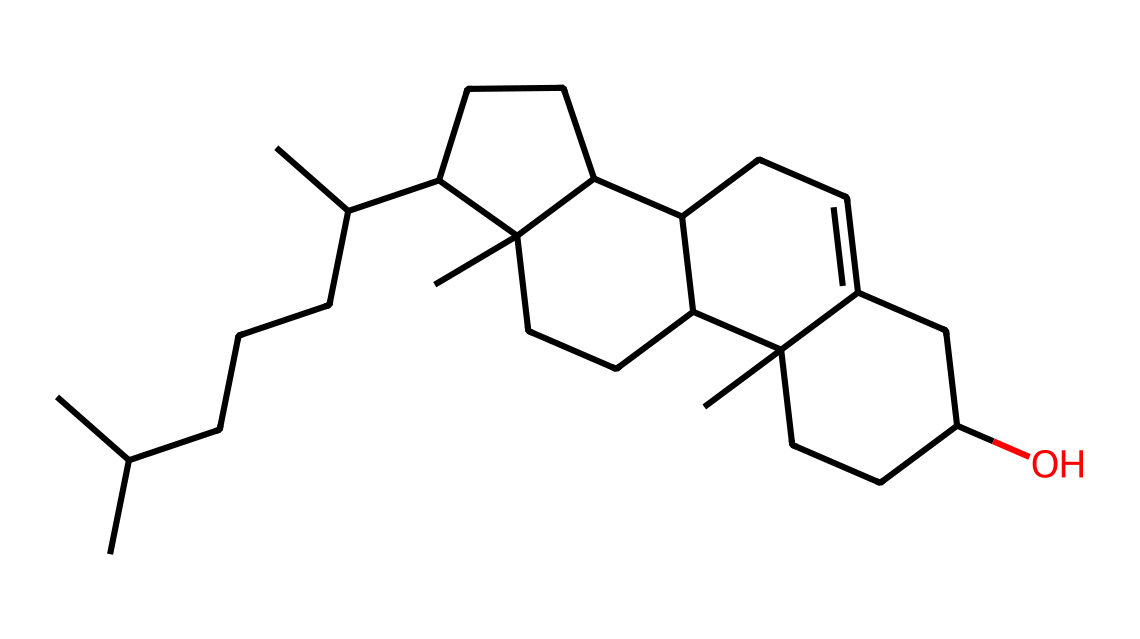What is the molecular formula for cholesterol based on the structure? To determine the molecular formula from the given SMILES, we need to identify the number of carbon (C), hydrogen (H), and oxygen (O) atoms present. Analyzing the structure, there are 27 carbon atoms, 46 hydrogen atoms, and 1 oxygen atom. Thus, the molecular formula is C27H46O.
Answer: C27H46O How many rings are present in the cholesterol structure? Looking at the SMILES representation, we notice brackets and numbers indicating connections and rings. Specifically, cholesterol has four fused rings visible in its structure, which is a characteristic feature of sterols. Counting the closed loops confirms that there are indeed four rings.
Answer: 4 What type of lipid category does cholesterol belong to? Cholesterol is classified as a sterol, which is a specific subclass of steroids that have a specific structure consisting of four interconnected carbon rings and a hydroxyl group. This categorization is pivotal in understanding its role in biological membranes and its function in makeup.
Answer: sterol Does cholesterol contain any functional groups? The structure of cholesterol indicates the presence of a hydroxyl group (-OH) attached to one of the rings, which classifies it as a sterol. The presence of this functional group influences the chemical properties and reactivity of cholesterol, playing a significant role in biological systems.
Answer: hydroxyl What is the significance of cholesterol in film actor makeup? Cholesterol plays a role in formulation, specifically in providing emollient properties and aiding in skin barrier functions. It contributes to the smooth application and hydration of makeup products, allowing for better adhesion and overall skin health, which is crucial for actors' appearance on film.
Answer: emollient 